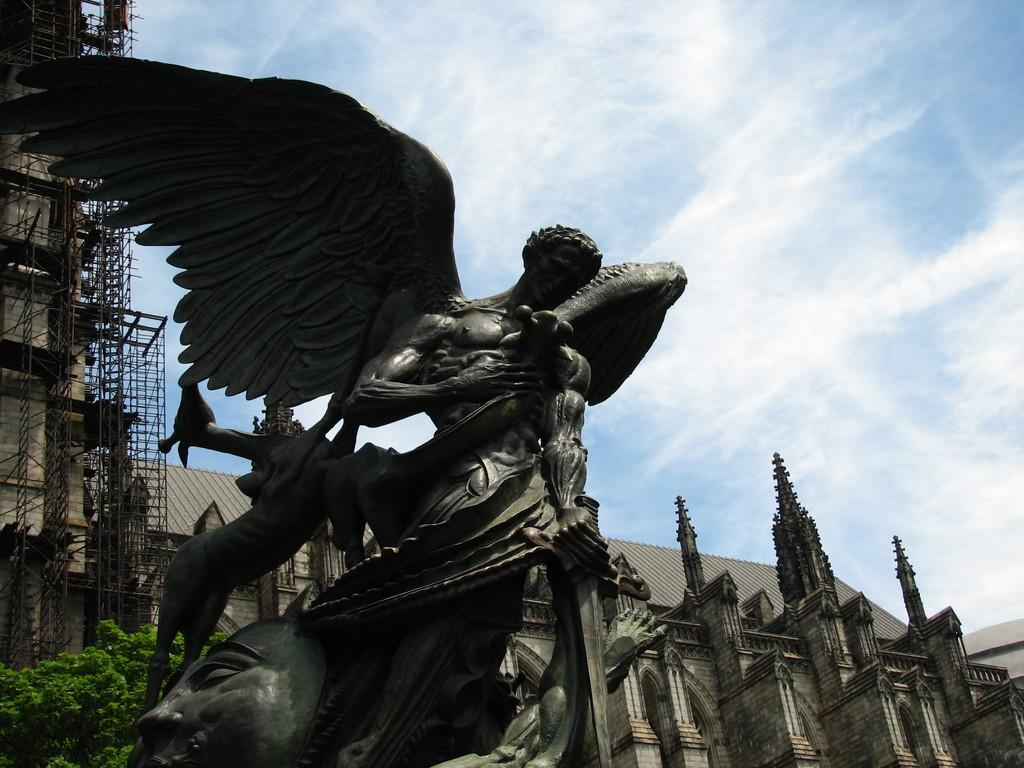What is the main subject in the image? There is a statue in the image. What can be seen behind the statue? There are buildings visible behind the statue. What type of infrastructure is present in the image? Roads are present in the image. What type of natural elements can be seen in the image? Trees are visible in the image. What else is present in the image besides the statue and natural elements? There are objects in the image. What is visible in the background of the image? The sky is visible in the background of the image. What can be seen in the sky? Clouds are present in the sky. What type of acoustics can be heard from the cactus in the image? There is no cactus present in the image, and therefore no acoustics can be heard from it. 